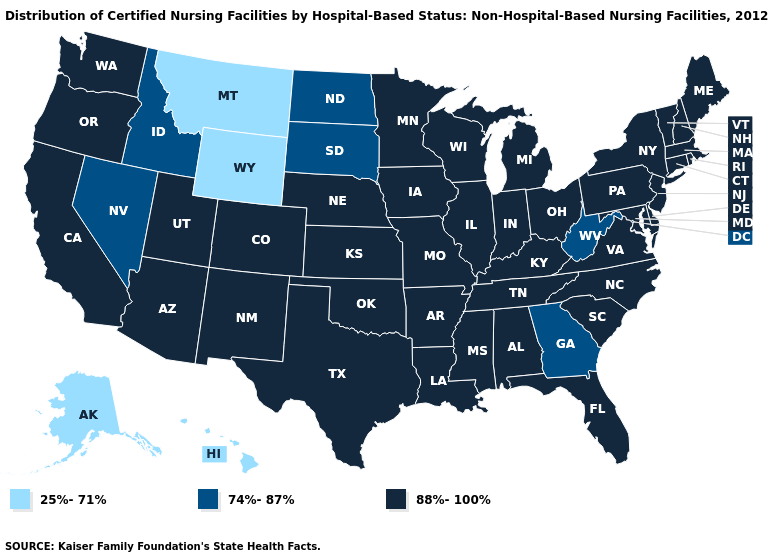Among the states that border Rhode Island , which have the highest value?
Quick response, please. Connecticut, Massachusetts. What is the highest value in the Northeast ?
Quick response, please. 88%-100%. What is the value of Virginia?
Give a very brief answer. 88%-100%. What is the value of Montana?
Be succinct. 25%-71%. What is the lowest value in states that border Pennsylvania?
Answer briefly. 74%-87%. Which states have the lowest value in the South?
Keep it brief. Georgia, West Virginia. Among the states that border Indiana , which have the highest value?
Concise answer only. Illinois, Kentucky, Michigan, Ohio. What is the value of Connecticut?
Short answer required. 88%-100%. What is the lowest value in the USA?
Give a very brief answer. 25%-71%. What is the value of Vermont?
Short answer required. 88%-100%. What is the value of Connecticut?
Give a very brief answer. 88%-100%. Does Kentucky have the highest value in the USA?
Short answer required. Yes. Which states have the highest value in the USA?
Give a very brief answer. Alabama, Arizona, Arkansas, California, Colorado, Connecticut, Delaware, Florida, Illinois, Indiana, Iowa, Kansas, Kentucky, Louisiana, Maine, Maryland, Massachusetts, Michigan, Minnesota, Mississippi, Missouri, Nebraska, New Hampshire, New Jersey, New Mexico, New York, North Carolina, Ohio, Oklahoma, Oregon, Pennsylvania, Rhode Island, South Carolina, Tennessee, Texas, Utah, Vermont, Virginia, Washington, Wisconsin. Does the first symbol in the legend represent the smallest category?
Write a very short answer. Yes. Among the states that border South Carolina , does North Carolina have the highest value?
Short answer required. Yes. 